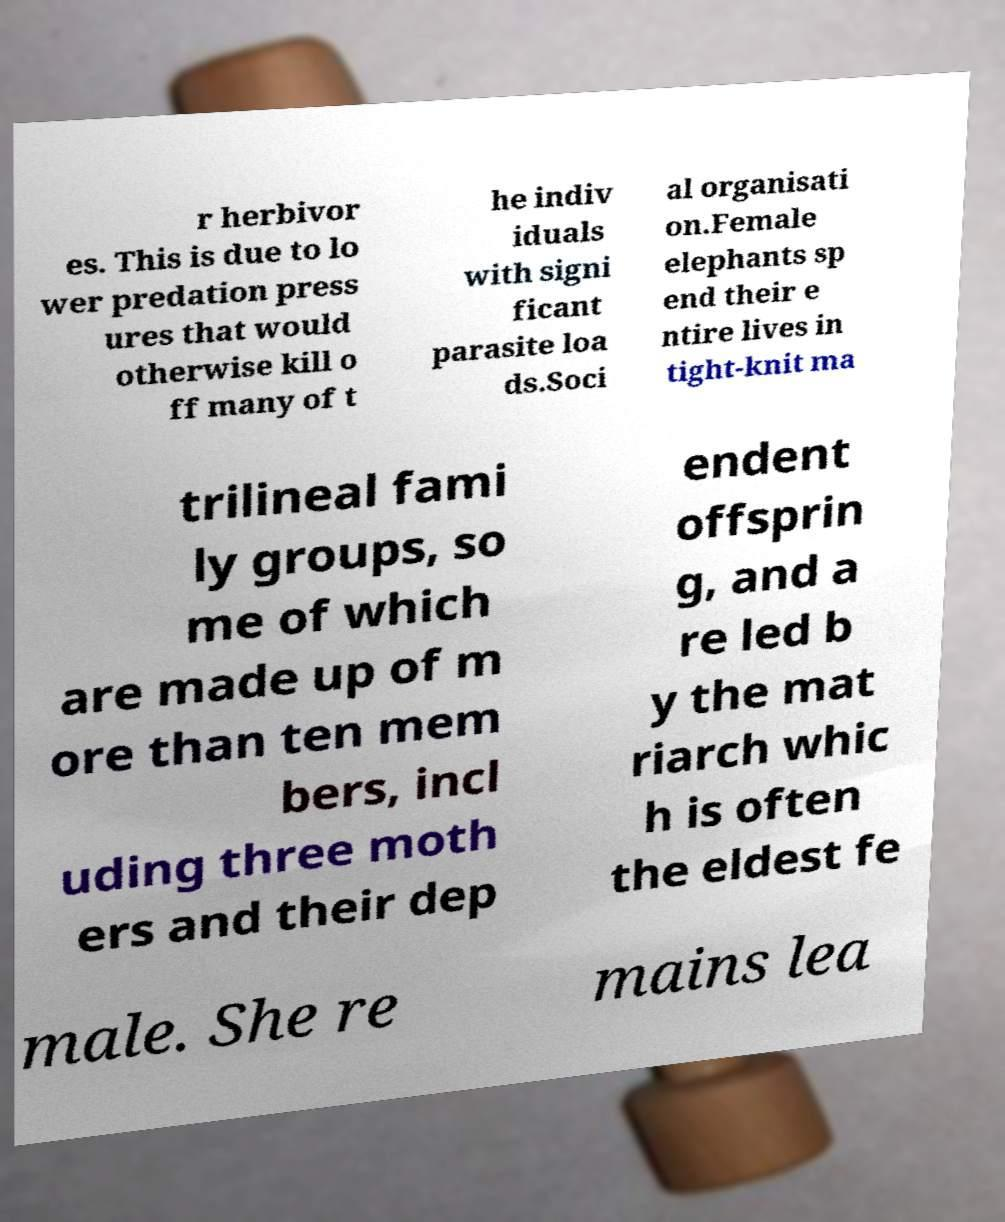Could you assist in decoding the text presented in this image and type it out clearly? r herbivor es. This is due to lo wer predation press ures that would otherwise kill o ff many of t he indiv iduals with signi ficant parasite loa ds.Soci al organisati on.Female elephants sp end their e ntire lives in tight-knit ma trilineal fami ly groups, so me of which are made up of m ore than ten mem bers, incl uding three moth ers and their dep endent offsprin g, and a re led b y the mat riarch whic h is often the eldest fe male. She re mains lea 